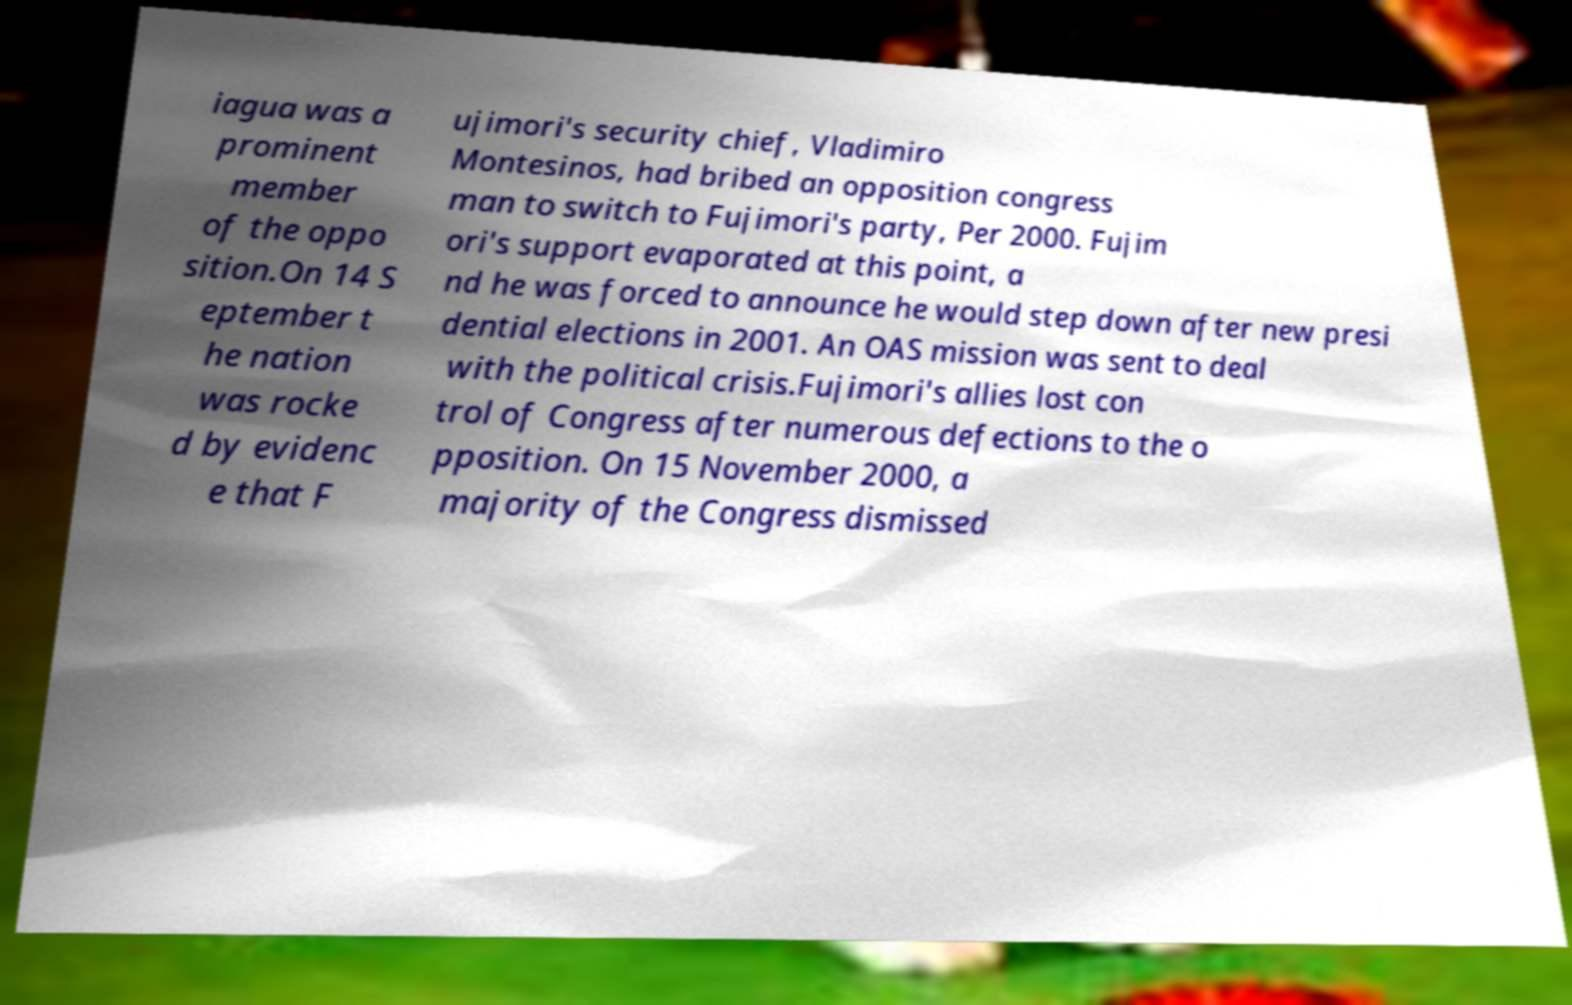Can you read and provide the text displayed in the image?This photo seems to have some interesting text. Can you extract and type it out for me? iagua was a prominent member of the oppo sition.On 14 S eptember t he nation was rocke d by evidenc e that F ujimori's security chief, Vladimiro Montesinos, had bribed an opposition congress man to switch to Fujimori's party, Per 2000. Fujim ori's support evaporated at this point, a nd he was forced to announce he would step down after new presi dential elections in 2001. An OAS mission was sent to deal with the political crisis.Fujimori's allies lost con trol of Congress after numerous defections to the o pposition. On 15 November 2000, a majority of the Congress dismissed 